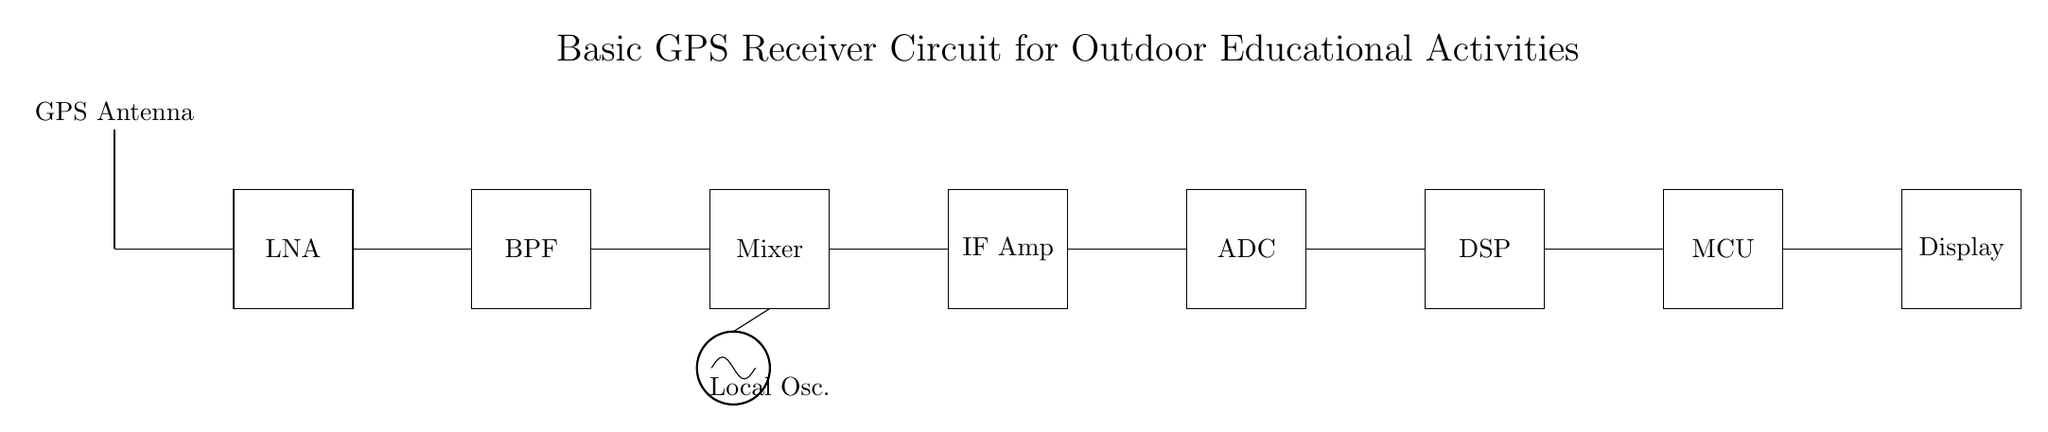What is the first component in this circuit? The first component shown in the circuit is the GPS Antenna, which is positioned at the top of the diagram and represents the starting point for signal reception.
Answer: GPS Antenna What type of filter is used in this circuit? The circuit includes a Bandpass Filter, as indicated by the label next to the rectangular block following the Low Noise Amplifier. This filter is essential for allowing signals within a certain frequency range to pass while attenuating others.
Answer: Bandpass Filter How many amplification stages are present in this circuit? There are two amplification stages indicated in the circuit: the Low Noise Amplifier and the IF Amplifier. These stages are crucial for boosting the signal strength to ensure accurate processing.
Answer: Two What does the interface between the ADC and DSP represent? The interface between the Analog-to-Digital Converter (ADC) and the Digital Signal Processor (DSP) represents the conversion of the analog signal into digital format, which allows for further digital processing of the GPS data.
Answer: Conversion What is the purpose of the Local Oscillator in this circuit? The Local Oscillator generates a frequency that is mixed with the received GPS signal in the mixer, which is necessary for down-converting the signal to an intermediate frequency for further processing in the IF Amplifier.
Answer: Frequency generation 